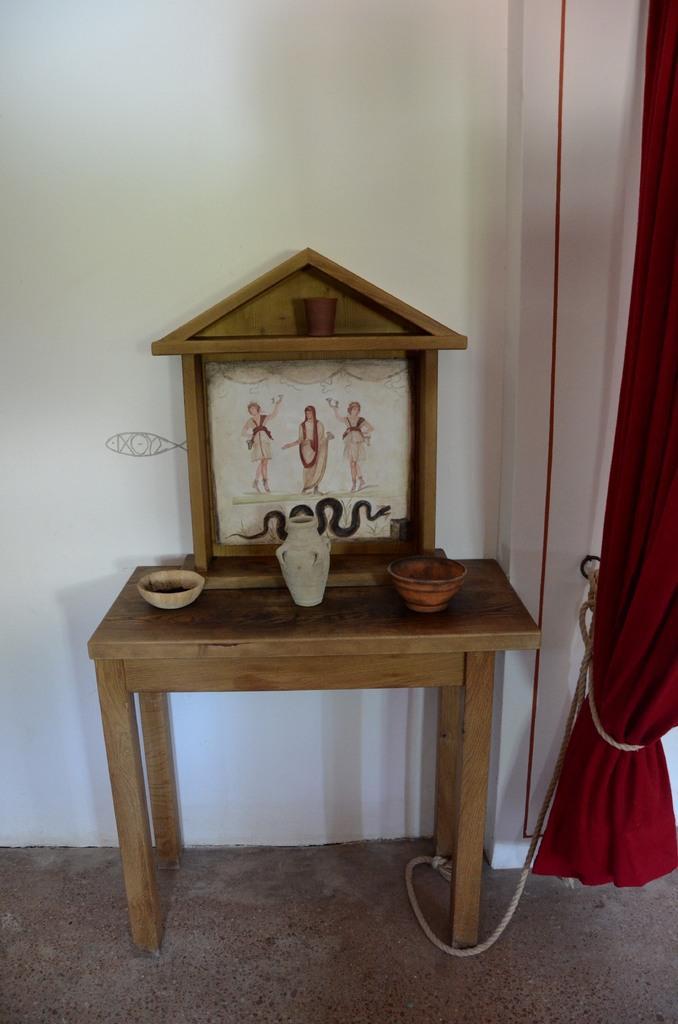Please provide a concise description of this image. In this picture we can see a frame, vase and two bowls on a wooden table. There is a curtain and ropes on the left side. We can see a wall in the background. 